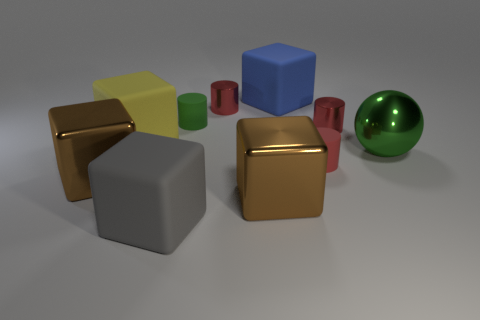How many red cylinders must be subtracted to get 1 red cylinders? 2 Subtract all cyan spheres. How many red cylinders are left? 3 Subtract 3 cubes. How many cubes are left? 2 Subtract all brown metallic blocks. How many blocks are left? 3 Subtract all gray cubes. How many cubes are left? 4 Subtract all green blocks. Subtract all yellow cylinders. How many blocks are left? 5 Subtract all cylinders. How many objects are left? 6 Subtract all blue rubber cylinders. Subtract all small red things. How many objects are left? 7 Add 6 gray rubber blocks. How many gray rubber blocks are left? 7 Add 5 gray rubber objects. How many gray rubber objects exist? 6 